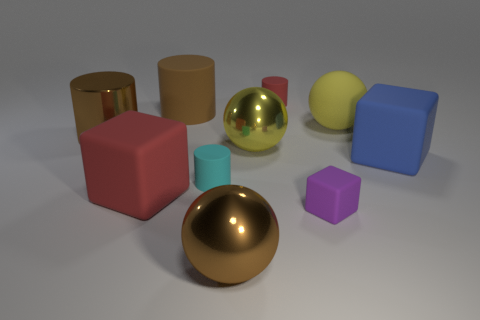Subtract all large brown metal balls. How many balls are left? 2 Add 7 big red things. How many big red things exist? 8 Subtract all cyan cylinders. How many cylinders are left? 3 Subtract 0 green blocks. How many objects are left? 10 Subtract all blocks. How many objects are left? 7 Subtract 1 cylinders. How many cylinders are left? 3 Subtract all gray cylinders. Subtract all brown spheres. How many cylinders are left? 4 Subtract all yellow spheres. How many blue blocks are left? 1 Subtract all blocks. Subtract all big matte objects. How many objects are left? 3 Add 7 matte cylinders. How many matte cylinders are left? 10 